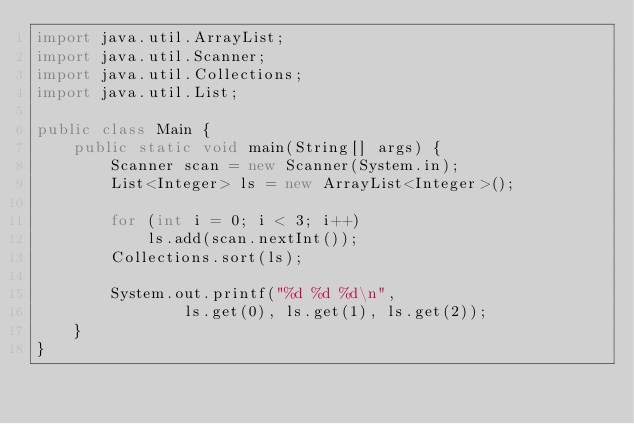<code> <loc_0><loc_0><loc_500><loc_500><_Java_>import java.util.ArrayList;
import java.util.Scanner;
import java.util.Collections;
import java.util.List;

public class Main {
	public static void main(String[] args) {
		Scanner scan = new Scanner(System.in);
		List<Integer> ls = new ArrayList<Integer>();

		for (int i = 0; i < 3; i++)
			ls.add(scan.nextInt());
		Collections.sort(ls);
		
		System.out.printf("%d %d %d\n",
				ls.get(0), ls.get(1), ls.get(2));
	}
}</code> 